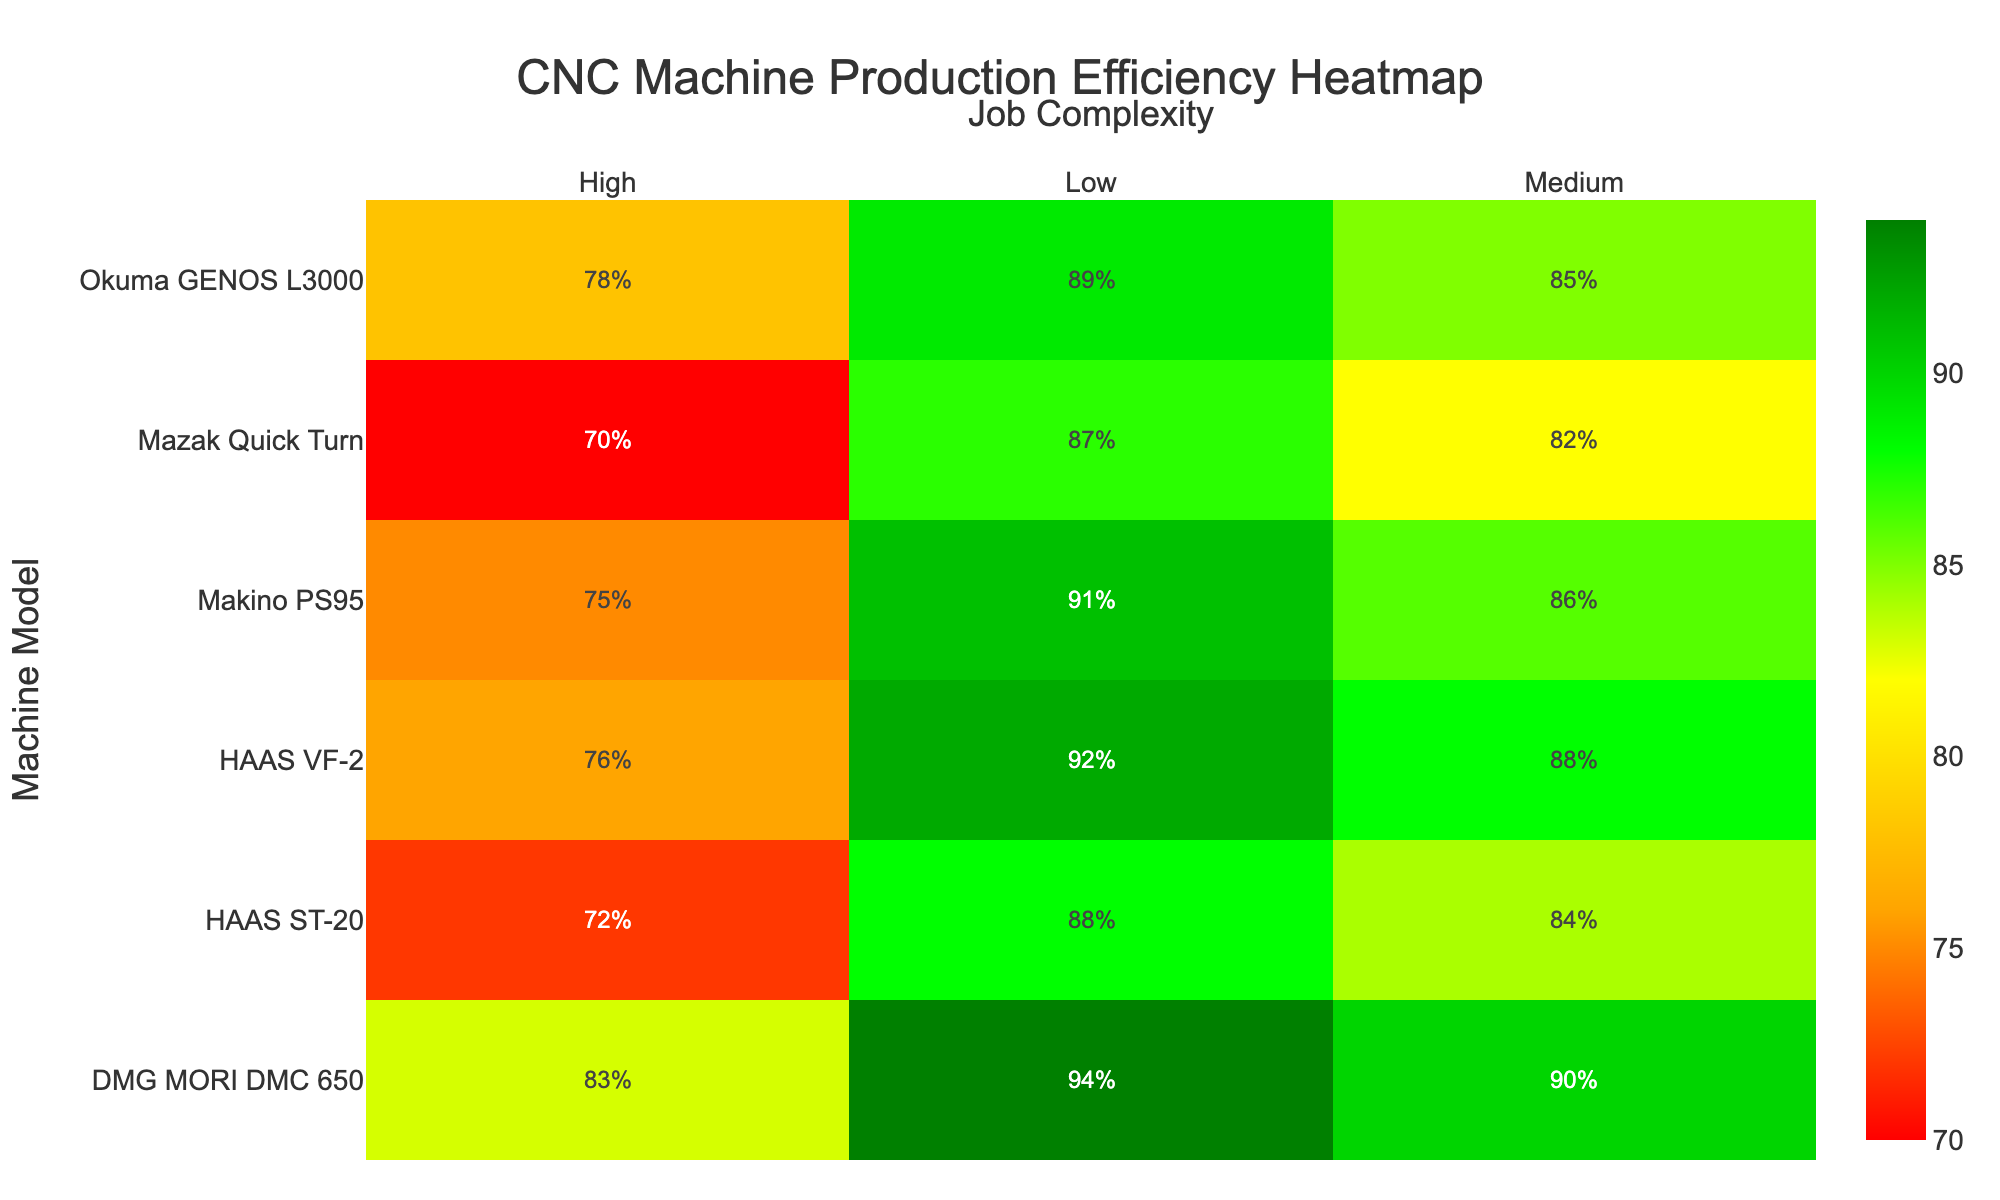What's the title of the heatmap? The title is displayed at the top center of the heatmap, reading 'CNC Machine Production Efficiency Heatmap'.
Answer: CNC Machine Production Efficiency Heatmap Which machine model has the highest production efficiency for high job complexity? Look at the cells under 'High' in the heatmap and identify the machine model with the highest percentage. DMG MORI DMC 650 has the highest percentage of 83%.
Answer: DMG MORI DMC 650 Compare the efficiency of the HAAS VF-2 and HAAS ST-20 for medium job complexity. Which is more efficient? Locate the cells for medium job complexity for both HAAS VF-2 and HAAS ST-20. HAAS VF-2 has 88%, and HAAS ST-20 has 84%.
Answer: HAAS VF-2 What is the production efficiency range (difference between highest and lowest efficiency) for the Makino PS95 across all job complexities? Identify the highest and lowest efficiencies for Makino PS95 in the heatmap. The highest is 91% (Low), and the lowest is 75% (High). The range is 91% - 75% = 16%.
Answer: 16% Which job complexity generally shows the lowest production efficiency across different machine models? Observe the general trend across the columns for 'Low', 'Medium', and 'High'. The 'High' job complexity typically shows the lowest efficiencies.
Answer: High How does the efficiency of Okuma GENOS L3000 change with increasing job complexity? Follow the row for Okuma GENOS L3000 and observe the percentages under 'Low', 'Medium', and 'High', which are 89%, 85%, and 78% respectively. The efficiency decreases with increasing job complexity.
Answer: Decreases Does any machine model have a production efficiency of over 90% for medium job complexity? Check the column for 'Medium' job complexity. DMG MORI DMC 650 is the only model with 90%.
Answer: Yes, DMG MORI DMC 650 What is the average production efficiency for HAAS VF-2 across all job complexities? Add up the efficiencies for HAAS VF-2 (92, 88, 76) and divide by the number of complexities (3). (92 + 88 + 76) / 3 = 85.33%.
Answer: 85.33% Among the given machine models, which one has the least variation in production efficiency across different job complexities? Calculate the range of efficiencies for each machine model and identify the smallest range. DMG MORI DMC 650 has efficiencies of 94, 90, and 83, giving a range of 94 - 83 = 11%.
Answer: DMG MORI DMC 650 